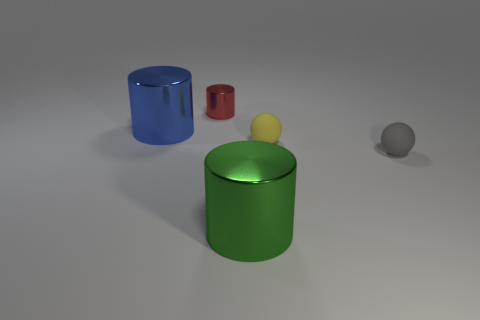Subtract all big cylinders. How many cylinders are left? 1 Add 4 small yellow matte objects. How many objects exist? 9 Subtract all blue cylinders. How many cylinders are left? 2 Subtract all cylinders. How many objects are left? 2 Subtract 2 balls. How many balls are left? 0 Add 5 large cylinders. How many large cylinders are left? 7 Add 2 gray rubber spheres. How many gray rubber spheres exist? 3 Subtract 0 cyan blocks. How many objects are left? 5 Subtract all cyan spheres. Subtract all yellow cylinders. How many spheres are left? 2 Subtract all small cyan objects. Subtract all rubber objects. How many objects are left? 3 